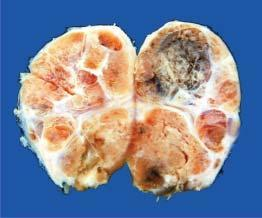what shows multiple nodules separated from each other by incomplete fibrous septa?
Answer the question using a single word or phrase. Cut surface 